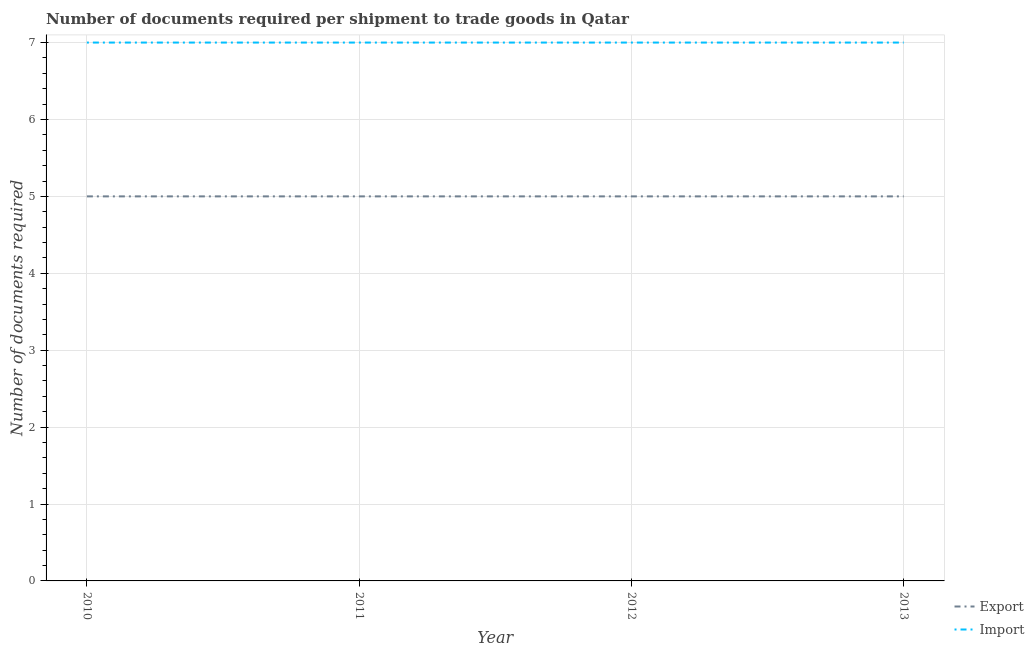Does the line corresponding to number of documents required to export goods intersect with the line corresponding to number of documents required to import goods?
Your answer should be compact. No. Is the number of lines equal to the number of legend labels?
Your answer should be compact. Yes. What is the number of documents required to export goods in 2013?
Provide a short and direct response. 5. Across all years, what is the maximum number of documents required to export goods?
Make the answer very short. 5. Across all years, what is the minimum number of documents required to export goods?
Ensure brevity in your answer.  5. What is the total number of documents required to export goods in the graph?
Give a very brief answer. 20. What is the difference between the number of documents required to export goods in 2010 and that in 2013?
Provide a short and direct response. 0. What is the difference between the number of documents required to export goods in 2012 and the number of documents required to import goods in 2013?
Give a very brief answer. -2. In the year 2010, what is the difference between the number of documents required to import goods and number of documents required to export goods?
Keep it short and to the point. 2. Is the difference between the number of documents required to export goods in 2010 and 2012 greater than the difference between the number of documents required to import goods in 2010 and 2012?
Your response must be concise. No. What is the difference between the highest and the lowest number of documents required to export goods?
Ensure brevity in your answer.  0. In how many years, is the number of documents required to import goods greater than the average number of documents required to import goods taken over all years?
Offer a very short reply. 0. Does the number of documents required to export goods monotonically increase over the years?
Provide a succinct answer. No. Is the number of documents required to import goods strictly greater than the number of documents required to export goods over the years?
Your answer should be compact. Yes. Is the number of documents required to export goods strictly less than the number of documents required to import goods over the years?
Provide a short and direct response. Yes. Does the graph contain grids?
Your answer should be very brief. Yes. How many legend labels are there?
Provide a short and direct response. 2. How are the legend labels stacked?
Offer a terse response. Vertical. What is the title of the graph?
Your response must be concise. Number of documents required per shipment to trade goods in Qatar. Does "Transport services" appear as one of the legend labels in the graph?
Your answer should be very brief. No. What is the label or title of the Y-axis?
Give a very brief answer. Number of documents required. What is the Number of documents required in Import in 2010?
Keep it short and to the point. 7. What is the Number of documents required in Import in 2012?
Ensure brevity in your answer.  7. What is the Number of documents required of Export in 2013?
Your answer should be very brief. 5. What is the Number of documents required in Import in 2013?
Your answer should be compact. 7. Across all years, what is the maximum Number of documents required of Import?
Your response must be concise. 7. Across all years, what is the minimum Number of documents required of Export?
Ensure brevity in your answer.  5. What is the difference between the Number of documents required of Export in 2010 and that in 2012?
Your answer should be compact. 0. What is the difference between the Number of documents required of Import in 2010 and that in 2013?
Your response must be concise. 0. What is the difference between the Number of documents required in Export in 2011 and that in 2012?
Give a very brief answer. 0. What is the difference between the Number of documents required in Import in 2011 and that in 2013?
Your answer should be very brief. 0. What is the difference between the Number of documents required in Export in 2010 and the Number of documents required in Import in 2012?
Ensure brevity in your answer.  -2. What is the difference between the Number of documents required of Export in 2010 and the Number of documents required of Import in 2013?
Keep it short and to the point. -2. What is the difference between the Number of documents required of Export in 2012 and the Number of documents required of Import in 2013?
Keep it short and to the point. -2. In the year 2010, what is the difference between the Number of documents required in Export and Number of documents required in Import?
Provide a short and direct response. -2. In the year 2012, what is the difference between the Number of documents required in Export and Number of documents required in Import?
Provide a short and direct response. -2. What is the ratio of the Number of documents required of Import in 2010 to that in 2012?
Give a very brief answer. 1. What is the ratio of the Number of documents required in Export in 2010 to that in 2013?
Make the answer very short. 1. What is the ratio of the Number of documents required of Import in 2010 to that in 2013?
Give a very brief answer. 1. What is the ratio of the Number of documents required of Export in 2011 to that in 2013?
Provide a short and direct response. 1. What is the ratio of the Number of documents required in Export in 2012 to that in 2013?
Your answer should be compact. 1. What is the ratio of the Number of documents required of Import in 2012 to that in 2013?
Offer a very short reply. 1. What is the difference between the highest and the second highest Number of documents required in Import?
Offer a terse response. 0. What is the difference between the highest and the lowest Number of documents required in Import?
Your answer should be very brief. 0. 